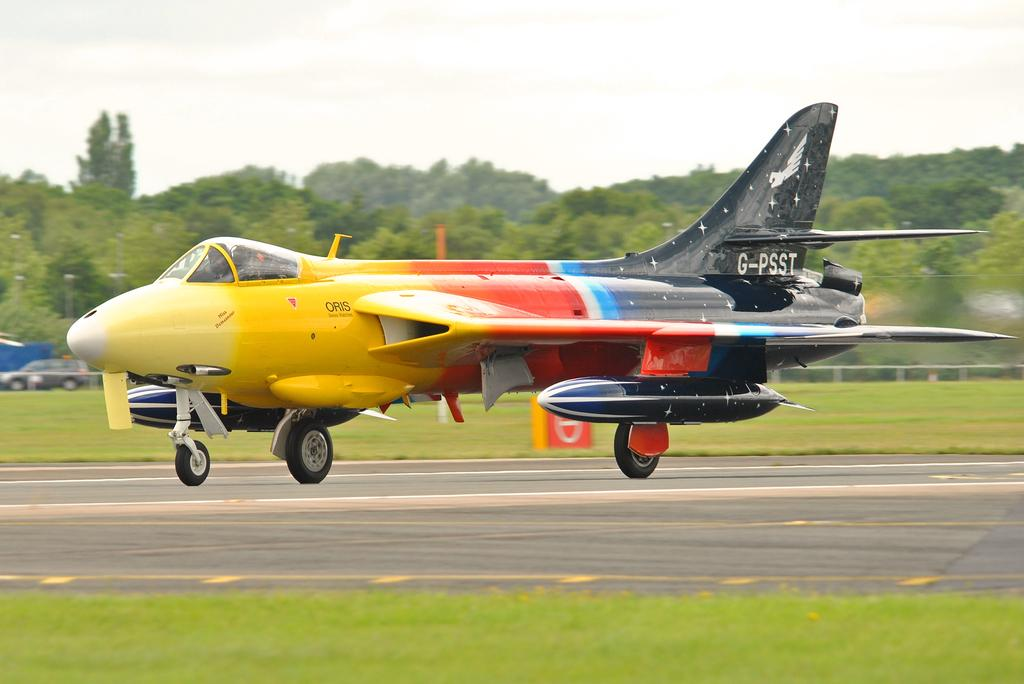Provide a one-sentence caption for the provided image. a multicolor fighter plane with tail number G-PSST landing. 